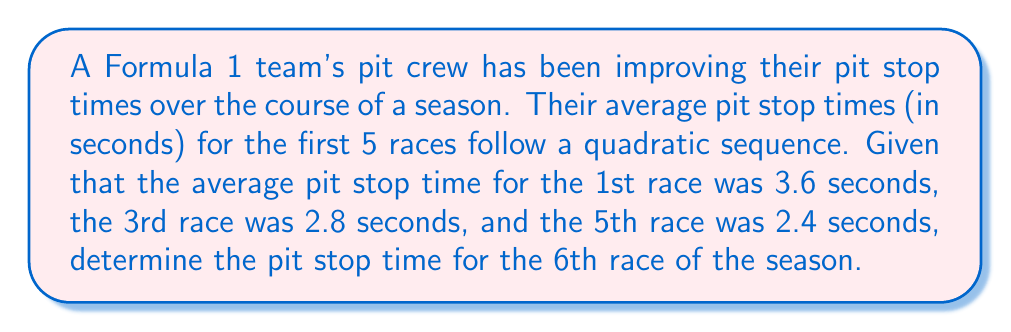Provide a solution to this math problem. Let's approach this step-by-step:

1) We're told that the sequence is quadratic, so it will have the form:
   $$a_n = an^2 + bn + c$$
   where $n$ is the race number and $a_n$ is the pit stop time for that race.

2) We're given three points:
   $(1, 3.6)$, $(3, 2.8)$, and $(5, 2.4)$

3) Substituting these into our quadratic formula:
   $$3.6 = a(1)^2 + b(1) + c$$
   $$2.8 = a(3)^2 + b(3) + c$$
   $$2.4 = a(5)^2 + b(5) + c$$

4) Simplifying:
   $$3.6 = a + b + c$$
   $$2.8 = 9a + 3b + c$$
   $$2.4 = 25a + 5b + c$$

5) Subtracting the first equation from the second and third:
   $$-0.8 = 8a + 2b$$
   $$-1.2 = 24a + 4b$$

6) Multiplying the first of these by 3 and subtracting from the second:
   $$-2.4 = 24a + 6b$$
   $$-1.2 = 24a + 4b$$
   $$-1.2 = 2b$$
   $$b = -0.6$$

7) Substituting back:
   $$-0.8 = 8a - 1.2$$
   $$0.4 = 8a$$
   $$a = 0.05$$

8) Using the first equation from step 4:
   $$3.6 = 0.05 + (-0.6) + c$$
   $$c = 4.15$$

9) So our sequence is:
   $$a_n = 0.05n^2 - 0.6n + 4.15$$

10) For the 6th race, $n = 6$:
    $$a_6 = 0.05(6)^2 - 0.6(6) + 4.15$$
    $$= 0.05(36) - 3.6 + 4.15$$
    $$= 1.8 - 3.6 + 4.15$$
    $$= 2.35$$

Therefore, the predicted pit stop time for the 6th race is 2.35 seconds.
Answer: 2.35 seconds 